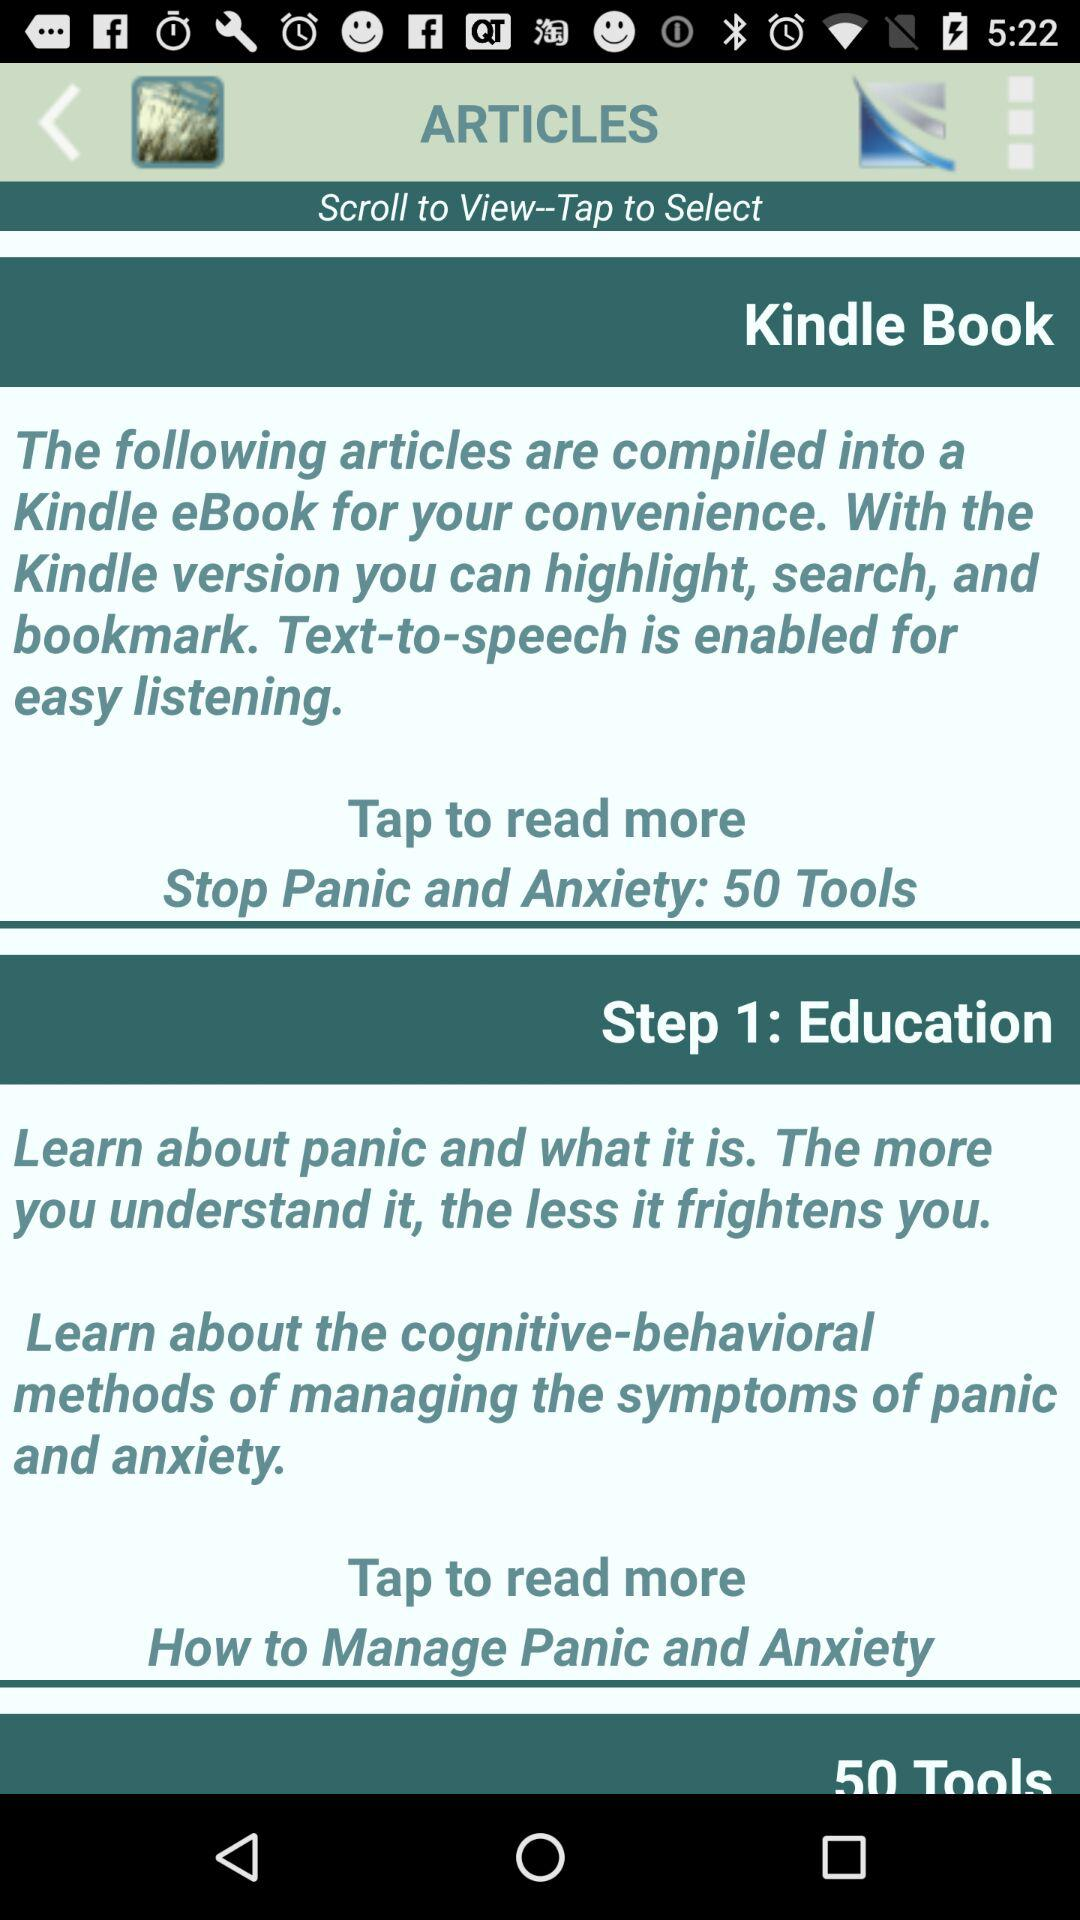What is the number of tools? The number of tools is 50. 